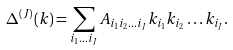Convert formula to latex. <formula><loc_0><loc_0><loc_500><loc_500>\Delta ^ { ( J ) } ( { k } ) = \sum _ { i _ { 1 } \dots i _ { J } } A _ { i _ { 1 } i _ { 2 } \dots i _ { J } } k _ { i _ { 1 } } k _ { i _ { 2 } } \dots k _ { i _ { J } } .</formula> 